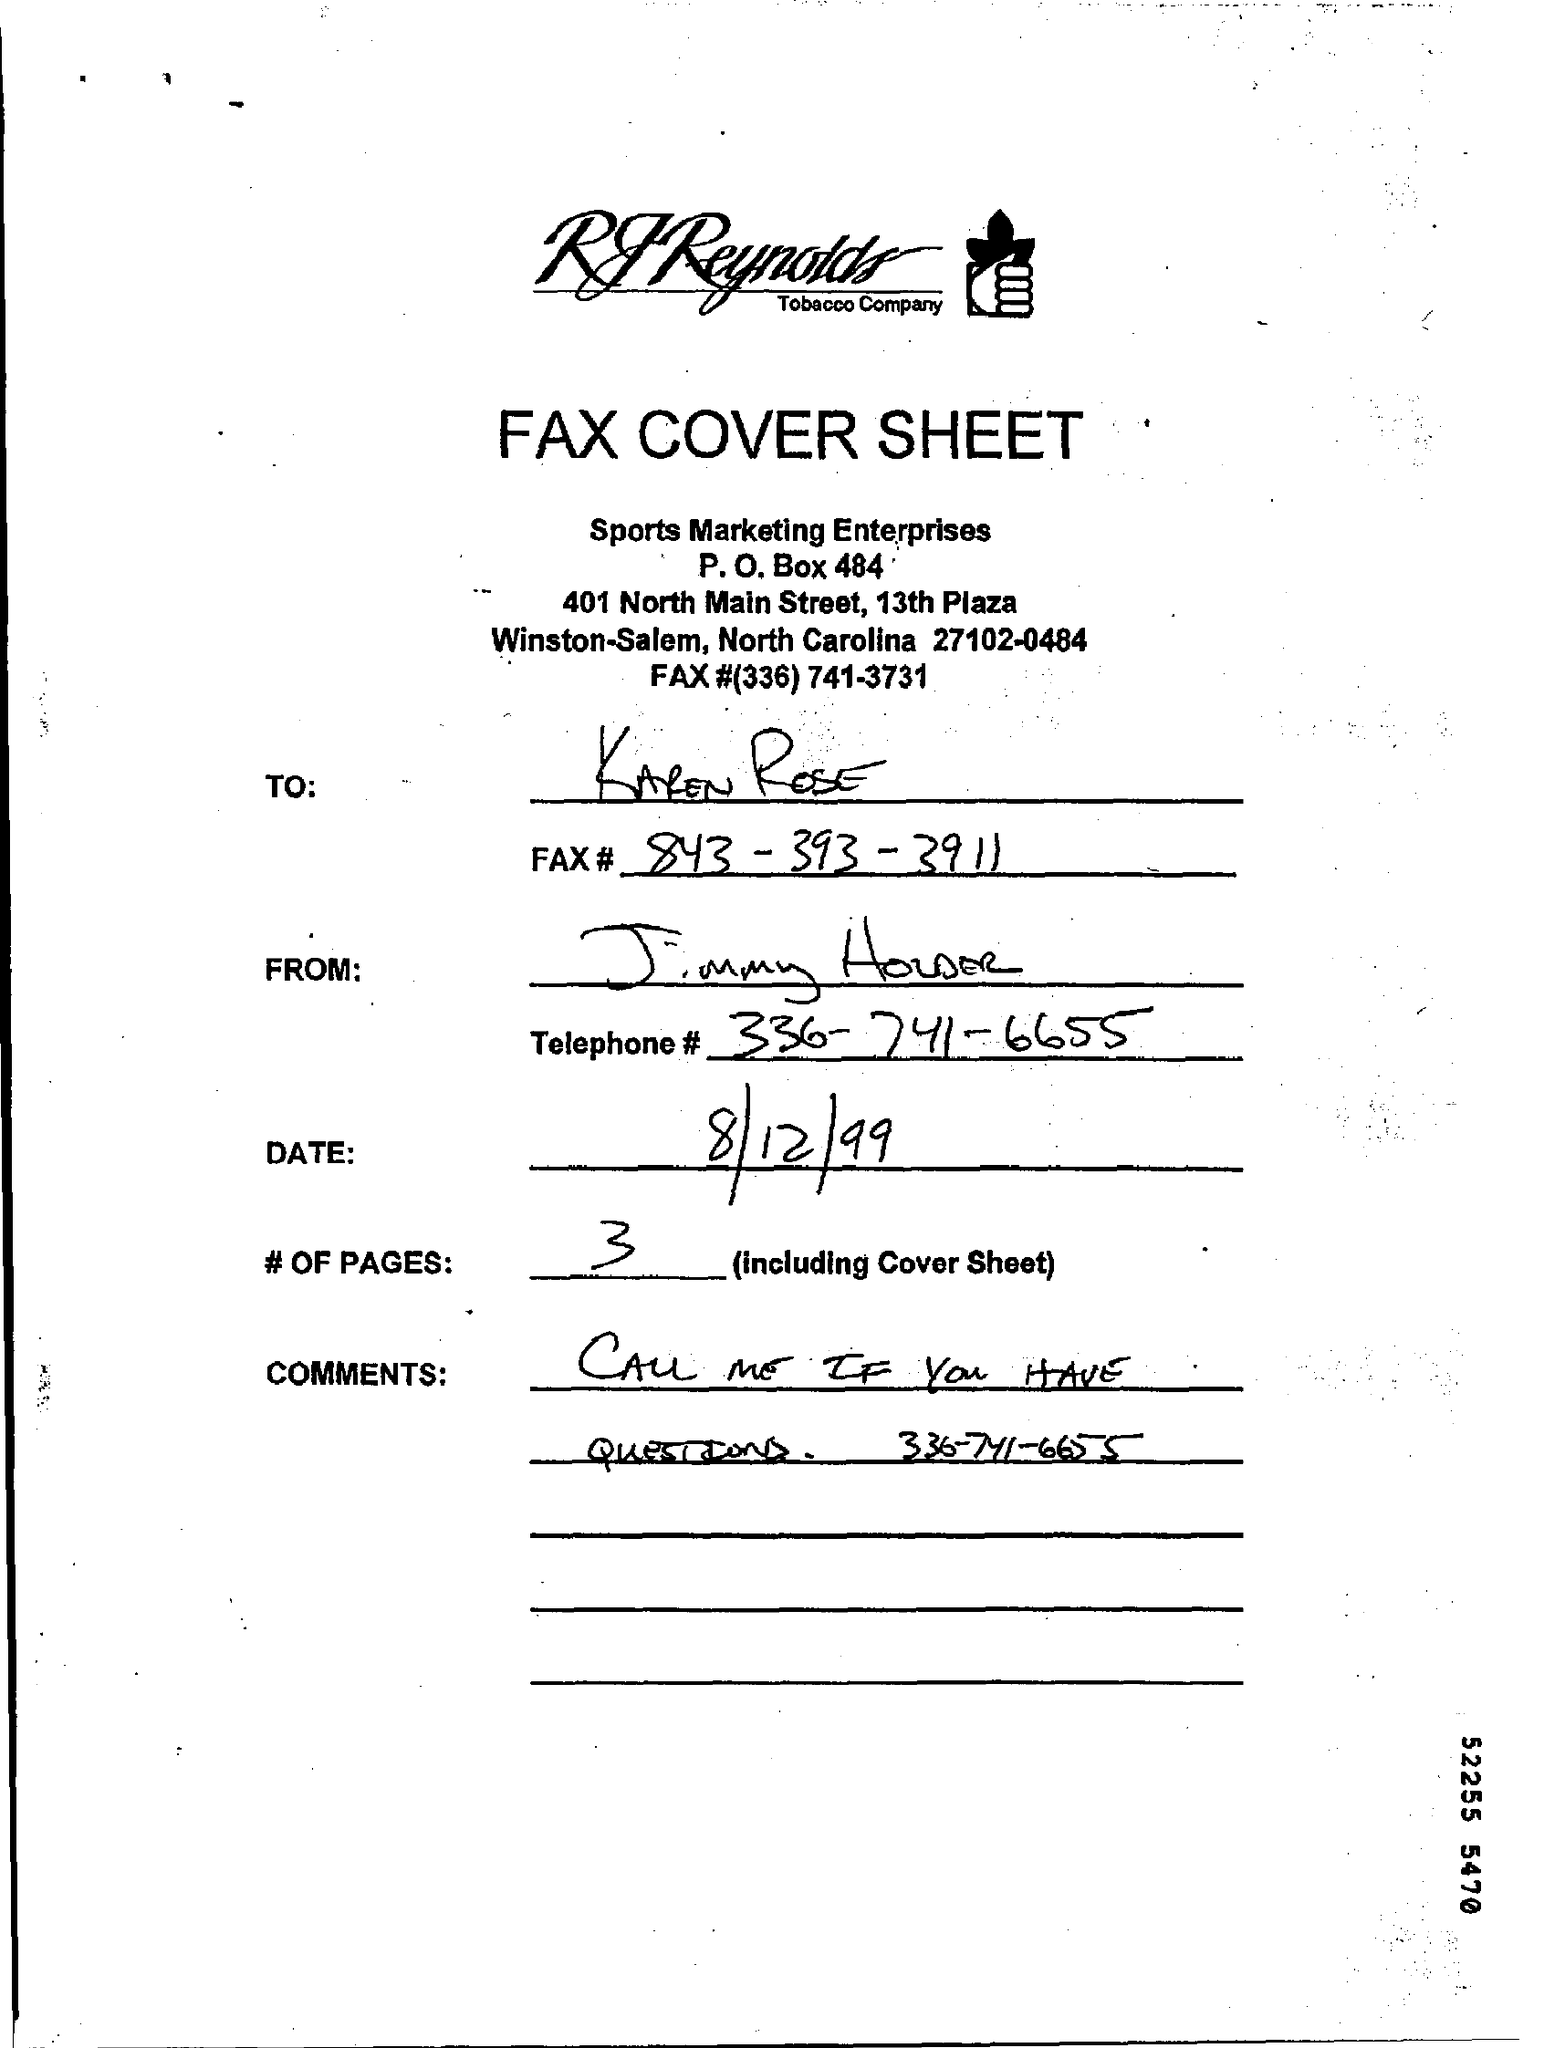List a handful of essential elements in this visual. Sports Marketing Enterprises is the name of the enterprise. The request is for three pages, including the cover sheet. The P.O. Box number is 484. The date mentioned is 8/12/99. I seek to ascertain the telephone number of Jimmy Houser, which is 336-741-6655. 